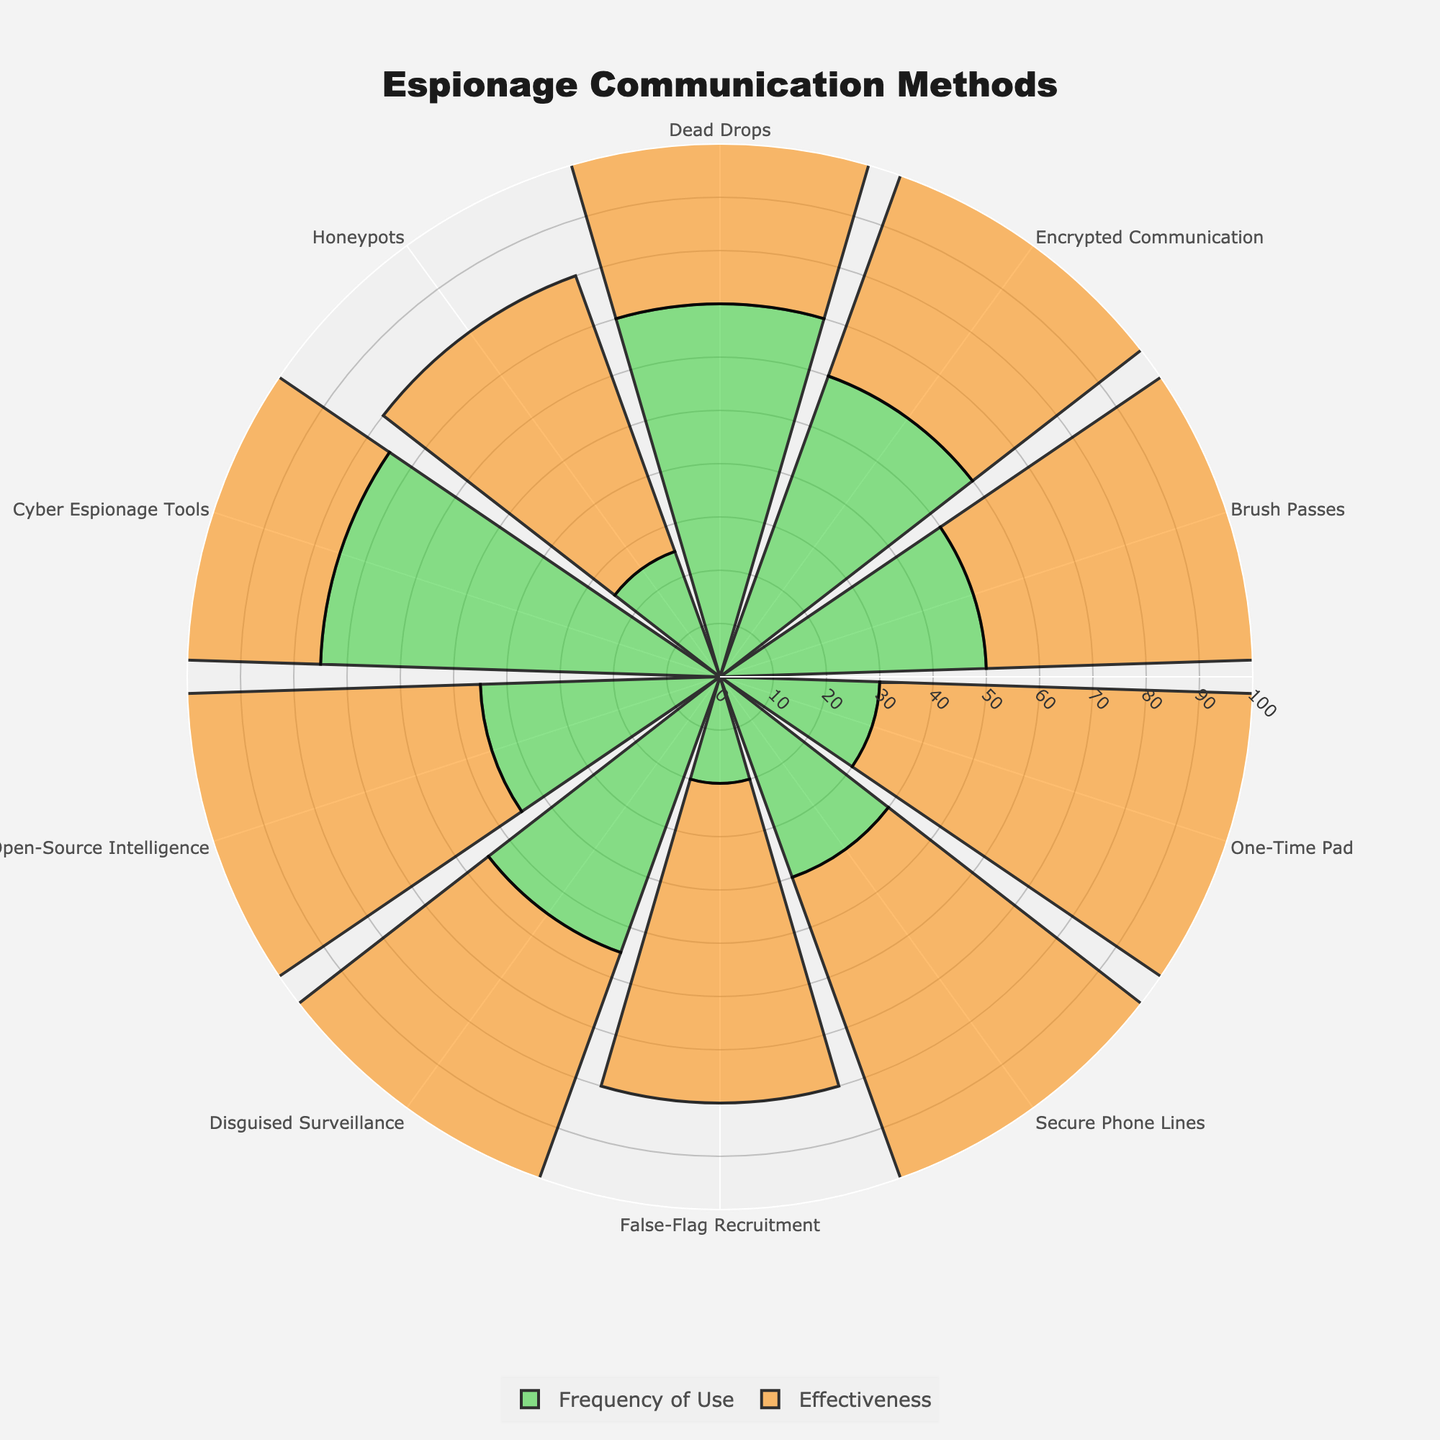which communication method is most frequently used? We look at the polar plot and identify the bar with the largest value in the "Frequency of Use" category.
Answer: Cyber Espionage Tools Which communication method is considered the most effective? By looking at the "Effectiveness" category, we observe the bar with the highest value.
Answer: One-Time Pad How many communication methods have a usage frequency greater than 50? Identify and count the bars in "Frequency of Use" that exceed the value of 50.
Answer: 5 Compare the effectiveness of Brush Passes and False-Flag Recruitment. Which one is more effective? Compare the values in the "Effectiveness" bars for Brush Passes and False-Flag Recruitment.
Answer: Brush Passes What is the range of effectiveness across all communication methods? Identify the minimum and maximum values in the "Effectiveness" category, then calculate the range (maximum - minimum).
Answer: 40 Which communication method is both highly used and highly effective? Look for a bar that has high values in both "Frequency of Use" and "Effectiveness."
Answer: Dead Drops If you average the frequency of use of Dead Drops and Cyber Espionage Tools, what value do you get? Add the Frequency of Use values for Dead Drops (70) and Cyber Espionage Tools (75), then divide by 2. (70 + 75) / 2 = 72.5
Answer: 72.5 Is there a positive correlation between frequency of use and effectiveness across the communication methods? Analyze if higher frequency of use corresponds with higher effectiveness visually in the plot.
Answer: No clear correlation How do Secure Phone Lines compare to Disguised Surveillance in terms of both usage frequency and effectiveness? Compare the bars for these two methods in both the Frequency of Use and Effectiveness categories.
Answer: Secure Phone Lines are less frequently used but more effective What is the average frequency of use across all communication methods? Sum all the frequency of use values and divide by the number of communication methods. (70 + 60 + 50 + 30 + 40 + 20 + 55 + 45 + 75 + 25) / 10 = 47
Answer: 47 